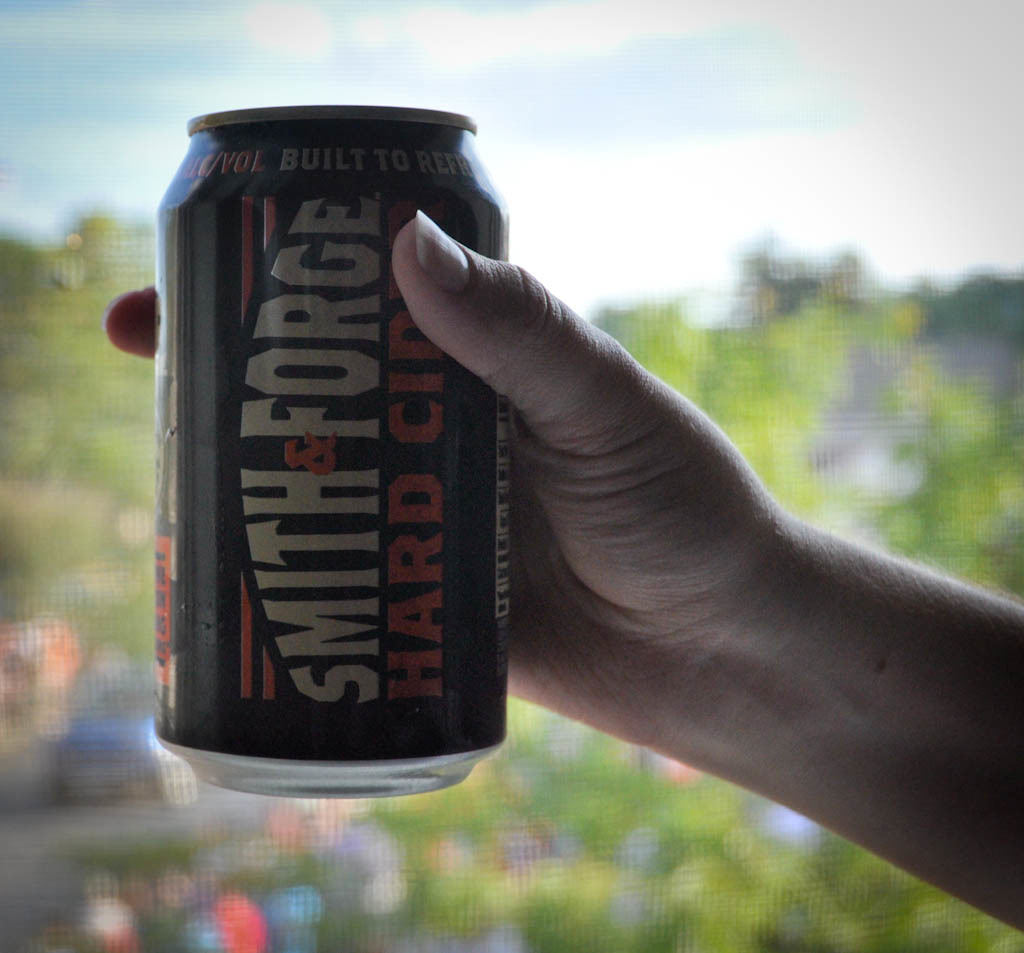Describe the human element in the image. How does it contribute to the photo's composition? A person's hand is prominently holding the can, using strong grip indicative of a firm hold. This human element adds a dynamic appeal to the composition, making the can appear more prominent and introducing a sense of scale and human interaction with the product. What impression does the label design of the can give about the brand? The label design on the can features rugged, industrial fonts and messaging that imply robustness and tradition. This could be appealing to consumers looking for authenticity and a strong, no-frills cider experience, mirroring the 'Built to Refresh' motto. 